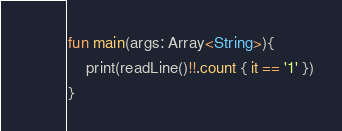<code> <loc_0><loc_0><loc_500><loc_500><_Kotlin_>fun main(args: Array<String>){
    print(readLine()!!.count { it == '1' })
}</code> 